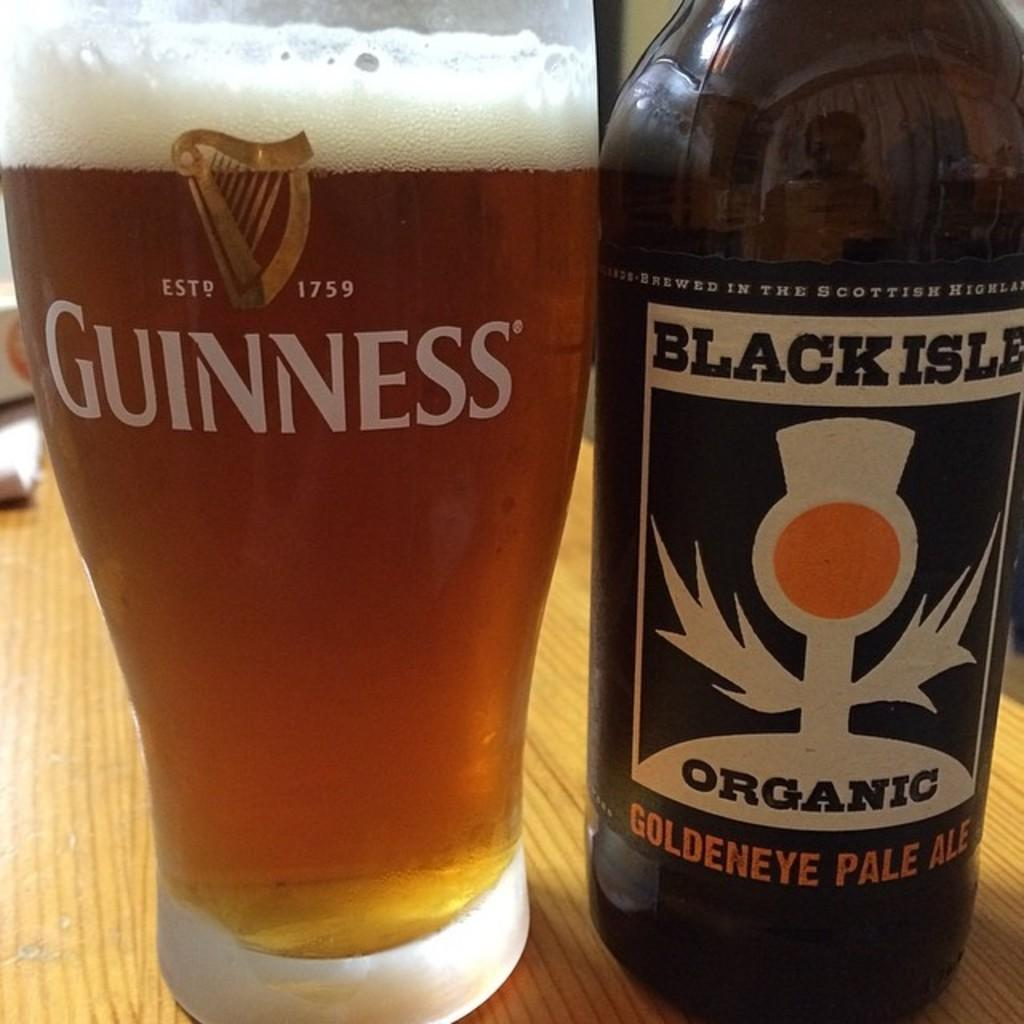What is the main object in the center of the image? There is a table in the center of the image. What items can be seen on the table? There is a box, a paper, a bottle, and a glass containing beer on the table. Can you describe the contents of the glass? The glass contains beer. What type of jam is being spread on the paper in the image? There is no jam present in the image; it features a table with a box, a paper, a bottle, and a glass containing beer. 